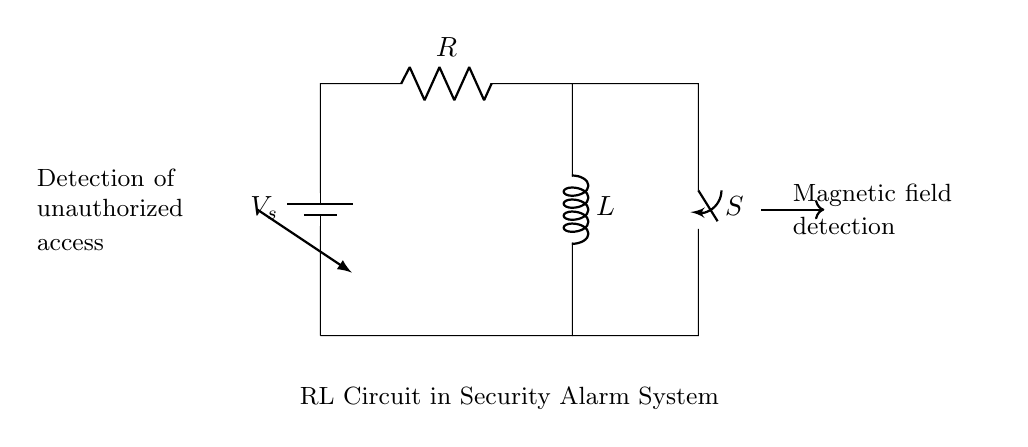What type of circuit is shown? The diagram depicts a Resistor-Inductor circuit, as indicated by the presence of both a resistor and an inductor in the schematic.
Answer: Resistor-Inductor What is the role of the switch in this circuit? The switch, labeled S, is designed to control the current flow through the circuit, allowing for the activation or deactivation of the RL circuit.
Answer: Control current flow What happens when the switch is closed? When the switch is closed, current flows through the circuit, causing the inductor to build up a magnetic field, which is essential for detection in the alarm system.
Answer: Current flows What is the purpose of the magnetic field detection? The magnetic field detection is used to sense unauthorized access, which is critical for security alarm functionality.
Answer: Detect unauthorized access What is the function of the resistor in this circuit? The resistor limits the current flowing through the circuit, helping to protect the components and control the voltage level across the inductor.
Answer: Limit current Explain why an RL circuit is preferred for alarm systems. RL circuits are preferred because they can store energy in the magnetic field, providing a faster response to changes in current, which is crucial for detecting intrusions effectively.
Answer: Faster response to changes 